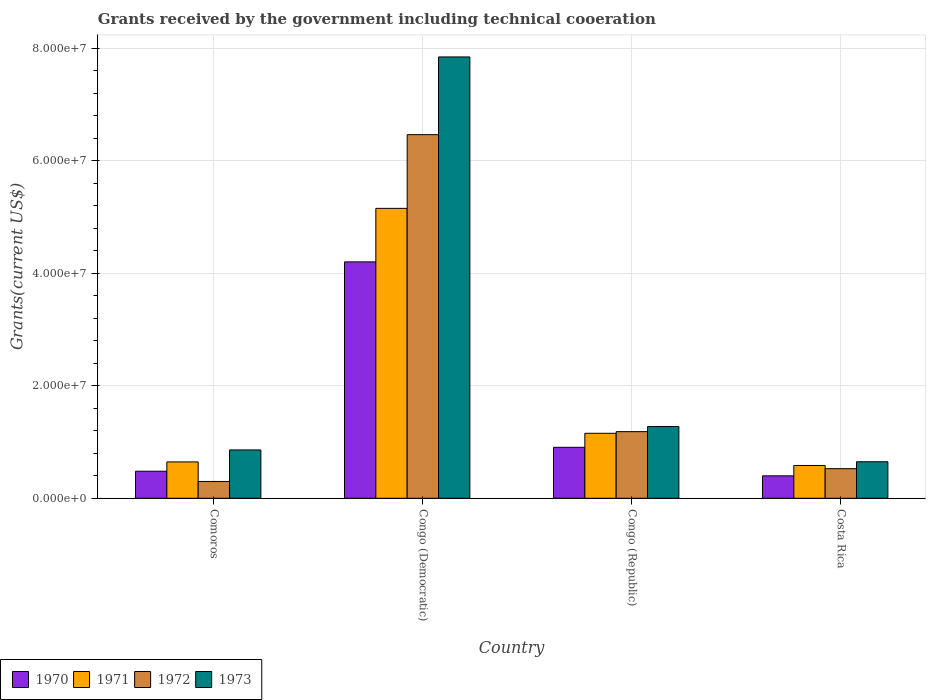How many different coloured bars are there?
Make the answer very short. 4. How many bars are there on the 4th tick from the left?
Your answer should be compact. 4. How many bars are there on the 2nd tick from the right?
Your answer should be compact. 4. What is the label of the 3rd group of bars from the left?
Offer a terse response. Congo (Republic). What is the total grants received by the government in 1972 in Congo (Republic)?
Your answer should be very brief. 1.18e+07. Across all countries, what is the maximum total grants received by the government in 1972?
Keep it short and to the point. 6.46e+07. Across all countries, what is the minimum total grants received by the government in 1972?
Provide a short and direct response. 2.99e+06. In which country was the total grants received by the government in 1971 maximum?
Your response must be concise. Congo (Democratic). In which country was the total grants received by the government in 1973 minimum?
Offer a terse response. Costa Rica. What is the total total grants received by the government in 1971 in the graph?
Your answer should be very brief. 7.54e+07. What is the difference between the total grants received by the government in 1971 in Congo (Democratic) and that in Congo (Republic)?
Make the answer very short. 4.00e+07. What is the difference between the total grants received by the government in 1970 in Comoros and the total grants received by the government in 1972 in Congo (Republic)?
Keep it short and to the point. -7.03e+06. What is the average total grants received by the government in 1970 per country?
Make the answer very short. 1.50e+07. What is the difference between the total grants received by the government of/in 1970 and total grants received by the government of/in 1971 in Comoros?
Keep it short and to the point. -1.65e+06. What is the ratio of the total grants received by the government in 1972 in Congo (Democratic) to that in Costa Rica?
Make the answer very short. 12.29. What is the difference between the highest and the second highest total grants received by the government in 1971?
Your answer should be compact. 4.00e+07. What is the difference between the highest and the lowest total grants received by the government in 1972?
Make the answer very short. 6.16e+07. Is it the case that in every country, the sum of the total grants received by the government in 1970 and total grants received by the government in 1971 is greater than the sum of total grants received by the government in 1972 and total grants received by the government in 1973?
Provide a short and direct response. No. What does the 2nd bar from the left in Costa Rica represents?
Make the answer very short. 1971. What does the 1st bar from the right in Congo (Democratic) represents?
Give a very brief answer. 1973. How many bars are there?
Provide a short and direct response. 16. Are all the bars in the graph horizontal?
Give a very brief answer. No. How many countries are there in the graph?
Your answer should be compact. 4. What is the difference between two consecutive major ticks on the Y-axis?
Ensure brevity in your answer.  2.00e+07. Are the values on the major ticks of Y-axis written in scientific E-notation?
Offer a terse response. Yes. How are the legend labels stacked?
Make the answer very short. Horizontal. What is the title of the graph?
Offer a very short reply. Grants received by the government including technical cooeration. What is the label or title of the X-axis?
Make the answer very short. Country. What is the label or title of the Y-axis?
Your response must be concise. Grants(current US$). What is the Grants(current US$) in 1970 in Comoros?
Ensure brevity in your answer.  4.81e+06. What is the Grants(current US$) in 1971 in Comoros?
Your response must be concise. 6.46e+06. What is the Grants(current US$) of 1972 in Comoros?
Ensure brevity in your answer.  2.99e+06. What is the Grants(current US$) in 1973 in Comoros?
Offer a terse response. 8.59e+06. What is the Grants(current US$) of 1970 in Congo (Democratic)?
Your answer should be very brief. 4.20e+07. What is the Grants(current US$) in 1971 in Congo (Democratic)?
Make the answer very short. 5.15e+07. What is the Grants(current US$) of 1972 in Congo (Democratic)?
Provide a short and direct response. 6.46e+07. What is the Grants(current US$) of 1973 in Congo (Democratic)?
Give a very brief answer. 7.84e+07. What is the Grants(current US$) in 1970 in Congo (Republic)?
Provide a succinct answer. 9.06e+06. What is the Grants(current US$) of 1971 in Congo (Republic)?
Your response must be concise. 1.16e+07. What is the Grants(current US$) in 1972 in Congo (Republic)?
Give a very brief answer. 1.18e+07. What is the Grants(current US$) in 1973 in Congo (Republic)?
Ensure brevity in your answer.  1.28e+07. What is the Grants(current US$) in 1970 in Costa Rica?
Keep it short and to the point. 3.99e+06. What is the Grants(current US$) in 1971 in Costa Rica?
Offer a very short reply. 5.83e+06. What is the Grants(current US$) in 1972 in Costa Rica?
Provide a succinct answer. 5.26e+06. What is the Grants(current US$) of 1973 in Costa Rica?
Your answer should be compact. 6.49e+06. Across all countries, what is the maximum Grants(current US$) in 1970?
Your answer should be very brief. 4.20e+07. Across all countries, what is the maximum Grants(current US$) of 1971?
Your response must be concise. 5.15e+07. Across all countries, what is the maximum Grants(current US$) of 1972?
Make the answer very short. 6.46e+07. Across all countries, what is the maximum Grants(current US$) of 1973?
Provide a succinct answer. 7.84e+07. Across all countries, what is the minimum Grants(current US$) in 1970?
Offer a terse response. 3.99e+06. Across all countries, what is the minimum Grants(current US$) in 1971?
Your answer should be compact. 5.83e+06. Across all countries, what is the minimum Grants(current US$) in 1972?
Your answer should be very brief. 2.99e+06. Across all countries, what is the minimum Grants(current US$) in 1973?
Keep it short and to the point. 6.49e+06. What is the total Grants(current US$) in 1970 in the graph?
Make the answer very short. 5.99e+07. What is the total Grants(current US$) of 1971 in the graph?
Provide a short and direct response. 7.54e+07. What is the total Grants(current US$) of 1972 in the graph?
Ensure brevity in your answer.  8.47e+07. What is the total Grants(current US$) in 1973 in the graph?
Give a very brief answer. 1.06e+08. What is the difference between the Grants(current US$) in 1970 in Comoros and that in Congo (Democratic)?
Give a very brief answer. -3.72e+07. What is the difference between the Grants(current US$) in 1971 in Comoros and that in Congo (Democratic)?
Your answer should be compact. -4.51e+07. What is the difference between the Grants(current US$) in 1972 in Comoros and that in Congo (Democratic)?
Provide a short and direct response. -6.16e+07. What is the difference between the Grants(current US$) in 1973 in Comoros and that in Congo (Democratic)?
Ensure brevity in your answer.  -6.98e+07. What is the difference between the Grants(current US$) of 1970 in Comoros and that in Congo (Republic)?
Your response must be concise. -4.25e+06. What is the difference between the Grants(current US$) of 1971 in Comoros and that in Congo (Republic)?
Your answer should be very brief. -5.09e+06. What is the difference between the Grants(current US$) of 1972 in Comoros and that in Congo (Republic)?
Your answer should be very brief. -8.85e+06. What is the difference between the Grants(current US$) of 1973 in Comoros and that in Congo (Republic)?
Your response must be concise. -4.16e+06. What is the difference between the Grants(current US$) of 1970 in Comoros and that in Costa Rica?
Give a very brief answer. 8.20e+05. What is the difference between the Grants(current US$) in 1971 in Comoros and that in Costa Rica?
Make the answer very short. 6.30e+05. What is the difference between the Grants(current US$) in 1972 in Comoros and that in Costa Rica?
Provide a succinct answer. -2.27e+06. What is the difference between the Grants(current US$) of 1973 in Comoros and that in Costa Rica?
Offer a terse response. 2.10e+06. What is the difference between the Grants(current US$) in 1970 in Congo (Democratic) and that in Congo (Republic)?
Provide a succinct answer. 3.30e+07. What is the difference between the Grants(current US$) in 1971 in Congo (Democratic) and that in Congo (Republic)?
Offer a terse response. 4.00e+07. What is the difference between the Grants(current US$) of 1972 in Congo (Democratic) and that in Congo (Republic)?
Ensure brevity in your answer.  5.28e+07. What is the difference between the Grants(current US$) in 1973 in Congo (Democratic) and that in Congo (Republic)?
Your answer should be compact. 6.57e+07. What is the difference between the Grants(current US$) in 1970 in Congo (Democratic) and that in Costa Rica?
Give a very brief answer. 3.80e+07. What is the difference between the Grants(current US$) of 1971 in Congo (Democratic) and that in Costa Rica?
Your answer should be compact. 4.57e+07. What is the difference between the Grants(current US$) in 1972 in Congo (Democratic) and that in Costa Rica?
Ensure brevity in your answer.  5.94e+07. What is the difference between the Grants(current US$) in 1973 in Congo (Democratic) and that in Costa Rica?
Give a very brief answer. 7.19e+07. What is the difference between the Grants(current US$) in 1970 in Congo (Republic) and that in Costa Rica?
Ensure brevity in your answer.  5.07e+06. What is the difference between the Grants(current US$) of 1971 in Congo (Republic) and that in Costa Rica?
Offer a terse response. 5.72e+06. What is the difference between the Grants(current US$) in 1972 in Congo (Republic) and that in Costa Rica?
Give a very brief answer. 6.58e+06. What is the difference between the Grants(current US$) in 1973 in Congo (Republic) and that in Costa Rica?
Provide a short and direct response. 6.26e+06. What is the difference between the Grants(current US$) of 1970 in Comoros and the Grants(current US$) of 1971 in Congo (Democratic)?
Offer a very short reply. -4.67e+07. What is the difference between the Grants(current US$) in 1970 in Comoros and the Grants(current US$) in 1972 in Congo (Democratic)?
Provide a short and direct response. -5.98e+07. What is the difference between the Grants(current US$) in 1970 in Comoros and the Grants(current US$) in 1973 in Congo (Democratic)?
Your answer should be very brief. -7.36e+07. What is the difference between the Grants(current US$) of 1971 in Comoros and the Grants(current US$) of 1972 in Congo (Democratic)?
Offer a terse response. -5.82e+07. What is the difference between the Grants(current US$) of 1971 in Comoros and the Grants(current US$) of 1973 in Congo (Democratic)?
Your answer should be very brief. -7.20e+07. What is the difference between the Grants(current US$) of 1972 in Comoros and the Grants(current US$) of 1973 in Congo (Democratic)?
Your answer should be very brief. -7.54e+07. What is the difference between the Grants(current US$) in 1970 in Comoros and the Grants(current US$) in 1971 in Congo (Republic)?
Offer a terse response. -6.74e+06. What is the difference between the Grants(current US$) of 1970 in Comoros and the Grants(current US$) of 1972 in Congo (Republic)?
Provide a short and direct response. -7.03e+06. What is the difference between the Grants(current US$) of 1970 in Comoros and the Grants(current US$) of 1973 in Congo (Republic)?
Your answer should be compact. -7.94e+06. What is the difference between the Grants(current US$) in 1971 in Comoros and the Grants(current US$) in 1972 in Congo (Republic)?
Provide a succinct answer. -5.38e+06. What is the difference between the Grants(current US$) of 1971 in Comoros and the Grants(current US$) of 1973 in Congo (Republic)?
Keep it short and to the point. -6.29e+06. What is the difference between the Grants(current US$) in 1972 in Comoros and the Grants(current US$) in 1973 in Congo (Republic)?
Ensure brevity in your answer.  -9.76e+06. What is the difference between the Grants(current US$) in 1970 in Comoros and the Grants(current US$) in 1971 in Costa Rica?
Make the answer very short. -1.02e+06. What is the difference between the Grants(current US$) of 1970 in Comoros and the Grants(current US$) of 1972 in Costa Rica?
Ensure brevity in your answer.  -4.50e+05. What is the difference between the Grants(current US$) in 1970 in Comoros and the Grants(current US$) in 1973 in Costa Rica?
Offer a terse response. -1.68e+06. What is the difference between the Grants(current US$) of 1971 in Comoros and the Grants(current US$) of 1972 in Costa Rica?
Make the answer very short. 1.20e+06. What is the difference between the Grants(current US$) of 1971 in Comoros and the Grants(current US$) of 1973 in Costa Rica?
Offer a very short reply. -3.00e+04. What is the difference between the Grants(current US$) in 1972 in Comoros and the Grants(current US$) in 1973 in Costa Rica?
Provide a succinct answer. -3.50e+06. What is the difference between the Grants(current US$) in 1970 in Congo (Democratic) and the Grants(current US$) in 1971 in Congo (Republic)?
Keep it short and to the point. 3.05e+07. What is the difference between the Grants(current US$) of 1970 in Congo (Democratic) and the Grants(current US$) of 1972 in Congo (Republic)?
Make the answer very short. 3.02e+07. What is the difference between the Grants(current US$) in 1970 in Congo (Democratic) and the Grants(current US$) in 1973 in Congo (Republic)?
Offer a terse response. 2.93e+07. What is the difference between the Grants(current US$) in 1971 in Congo (Democratic) and the Grants(current US$) in 1972 in Congo (Republic)?
Make the answer very short. 3.97e+07. What is the difference between the Grants(current US$) of 1971 in Congo (Democratic) and the Grants(current US$) of 1973 in Congo (Republic)?
Give a very brief answer. 3.88e+07. What is the difference between the Grants(current US$) in 1972 in Congo (Democratic) and the Grants(current US$) in 1973 in Congo (Republic)?
Keep it short and to the point. 5.19e+07. What is the difference between the Grants(current US$) in 1970 in Congo (Democratic) and the Grants(current US$) in 1971 in Costa Rica?
Provide a succinct answer. 3.62e+07. What is the difference between the Grants(current US$) of 1970 in Congo (Democratic) and the Grants(current US$) of 1972 in Costa Rica?
Ensure brevity in your answer.  3.68e+07. What is the difference between the Grants(current US$) of 1970 in Congo (Democratic) and the Grants(current US$) of 1973 in Costa Rica?
Offer a terse response. 3.55e+07. What is the difference between the Grants(current US$) in 1971 in Congo (Democratic) and the Grants(current US$) in 1972 in Costa Rica?
Ensure brevity in your answer.  4.63e+07. What is the difference between the Grants(current US$) in 1971 in Congo (Democratic) and the Grants(current US$) in 1973 in Costa Rica?
Offer a terse response. 4.50e+07. What is the difference between the Grants(current US$) in 1972 in Congo (Democratic) and the Grants(current US$) in 1973 in Costa Rica?
Offer a terse response. 5.81e+07. What is the difference between the Grants(current US$) of 1970 in Congo (Republic) and the Grants(current US$) of 1971 in Costa Rica?
Your response must be concise. 3.23e+06. What is the difference between the Grants(current US$) of 1970 in Congo (Republic) and the Grants(current US$) of 1972 in Costa Rica?
Keep it short and to the point. 3.80e+06. What is the difference between the Grants(current US$) of 1970 in Congo (Republic) and the Grants(current US$) of 1973 in Costa Rica?
Ensure brevity in your answer.  2.57e+06. What is the difference between the Grants(current US$) in 1971 in Congo (Republic) and the Grants(current US$) in 1972 in Costa Rica?
Offer a terse response. 6.29e+06. What is the difference between the Grants(current US$) of 1971 in Congo (Republic) and the Grants(current US$) of 1973 in Costa Rica?
Give a very brief answer. 5.06e+06. What is the difference between the Grants(current US$) of 1972 in Congo (Republic) and the Grants(current US$) of 1973 in Costa Rica?
Offer a terse response. 5.35e+06. What is the average Grants(current US$) in 1970 per country?
Your response must be concise. 1.50e+07. What is the average Grants(current US$) of 1971 per country?
Your answer should be compact. 1.88e+07. What is the average Grants(current US$) in 1972 per country?
Provide a succinct answer. 2.12e+07. What is the average Grants(current US$) in 1973 per country?
Offer a terse response. 2.66e+07. What is the difference between the Grants(current US$) of 1970 and Grants(current US$) of 1971 in Comoros?
Provide a succinct answer. -1.65e+06. What is the difference between the Grants(current US$) of 1970 and Grants(current US$) of 1972 in Comoros?
Offer a terse response. 1.82e+06. What is the difference between the Grants(current US$) in 1970 and Grants(current US$) in 1973 in Comoros?
Offer a very short reply. -3.78e+06. What is the difference between the Grants(current US$) in 1971 and Grants(current US$) in 1972 in Comoros?
Provide a succinct answer. 3.47e+06. What is the difference between the Grants(current US$) in 1971 and Grants(current US$) in 1973 in Comoros?
Provide a short and direct response. -2.13e+06. What is the difference between the Grants(current US$) of 1972 and Grants(current US$) of 1973 in Comoros?
Your response must be concise. -5.60e+06. What is the difference between the Grants(current US$) of 1970 and Grants(current US$) of 1971 in Congo (Democratic)?
Offer a very short reply. -9.51e+06. What is the difference between the Grants(current US$) of 1970 and Grants(current US$) of 1972 in Congo (Democratic)?
Offer a very short reply. -2.26e+07. What is the difference between the Grants(current US$) of 1970 and Grants(current US$) of 1973 in Congo (Democratic)?
Your answer should be compact. -3.64e+07. What is the difference between the Grants(current US$) of 1971 and Grants(current US$) of 1972 in Congo (Democratic)?
Ensure brevity in your answer.  -1.31e+07. What is the difference between the Grants(current US$) in 1971 and Grants(current US$) in 1973 in Congo (Democratic)?
Offer a very short reply. -2.69e+07. What is the difference between the Grants(current US$) in 1972 and Grants(current US$) in 1973 in Congo (Democratic)?
Give a very brief answer. -1.38e+07. What is the difference between the Grants(current US$) of 1970 and Grants(current US$) of 1971 in Congo (Republic)?
Provide a succinct answer. -2.49e+06. What is the difference between the Grants(current US$) in 1970 and Grants(current US$) in 1972 in Congo (Republic)?
Your answer should be compact. -2.78e+06. What is the difference between the Grants(current US$) in 1970 and Grants(current US$) in 1973 in Congo (Republic)?
Your response must be concise. -3.69e+06. What is the difference between the Grants(current US$) in 1971 and Grants(current US$) in 1973 in Congo (Republic)?
Ensure brevity in your answer.  -1.20e+06. What is the difference between the Grants(current US$) in 1972 and Grants(current US$) in 1973 in Congo (Republic)?
Offer a terse response. -9.10e+05. What is the difference between the Grants(current US$) of 1970 and Grants(current US$) of 1971 in Costa Rica?
Your answer should be very brief. -1.84e+06. What is the difference between the Grants(current US$) in 1970 and Grants(current US$) in 1972 in Costa Rica?
Your answer should be very brief. -1.27e+06. What is the difference between the Grants(current US$) in 1970 and Grants(current US$) in 1973 in Costa Rica?
Offer a terse response. -2.50e+06. What is the difference between the Grants(current US$) of 1971 and Grants(current US$) of 1972 in Costa Rica?
Your answer should be compact. 5.70e+05. What is the difference between the Grants(current US$) of 1971 and Grants(current US$) of 1973 in Costa Rica?
Your response must be concise. -6.60e+05. What is the difference between the Grants(current US$) in 1972 and Grants(current US$) in 1973 in Costa Rica?
Offer a very short reply. -1.23e+06. What is the ratio of the Grants(current US$) of 1970 in Comoros to that in Congo (Democratic)?
Provide a short and direct response. 0.11. What is the ratio of the Grants(current US$) of 1971 in Comoros to that in Congo (Democratic)?
Your answer should be very brief. 0.13. What is the ratio of the Grants(current US$) of 1972 in Comoros to that in Congo (Democratic)?
Make the answer very short. 0.05. What is the ratio of the Grants(current US$) of 1973 in Comoros to that in Congo (Democratic)?
Offer a terse response. 0.11. What is the ratio of the Grants(current US$) in 1970 in Comoros to that in Congo (Republic)?
Ensure brevity in your answer.  0.53. What is the ratio of the Grants(current US$) in 1971 in Comoros to that in Congo (Republic)?
Provide a succinct answer. 0.56. What is the ratio of the Grants(current US$) in 1972 in Comoros to that in Congo (Republic)?
Offer a very short reply. 0.25. What is the ratio of the Grants(current US$) of 1973 in Comoros to that in Congo (Republic)?
Give a very brief answer. 0.67. What is the ratio of the Grants(current US$) in 1970 in Comoros to that in Costa Rica?
Keep it short and to the point. 1.21. What is the ratio of the Grants(current US$) in 1971 in Comoros to that in Costa Rica?
Keep it short and to the point. 1.11. What is the ratio of the Grants(current US$) of 1972 in Comoros to that in Costa Rica?
Offer a very short reply. 0.57. What is the ratio of the Grants(current US$) of 1973 in Comoros to that in Costa Rica?
Give a very brief answer. 1.32. What is the ratio of the Grants(current US$) of 1970 in Congo (Democratic) to that in Congo (Republic)?
Make the answer very short. 4.64. What is the ratio of the Grants(current US$) of 1971 in Congo (Democratic) to that in Congo (Republic)?
Make the answer very short. 4.46. What is the ratio of the Grants(current US$) of 1972 in Congo (Democratic) to that in Congo (Republic)?
Your answer should be compact. 5.46. What is the ratio of the Grants(current US$) of 1973 in Congo (Democratic) to that in Congo (Republic)?
Offer a very short reply. 6.15. What is the ratio of the Grants(current US$) in 1970 in Congo (Democratic) to that in Costa Rica?
Your answer should be very brief. 10.53. What is the ratio of the Grants(current US$) in 1971 in Congo (Democratic) to that in Costa Rica?
Ensure brevity in your answer.  8.84. What is the ratio of the Grants(current US$) in 1972 in Congo (Democratic) to that in Costa Rica?
Provide a short and direct response. 12.29. What is the ratio of the Grants(current US$) in 1973 in Congo (Democratic) to that in Costa Rica?
Ensure brevity in your answer.  12.08. What is the ratio of the Grants(current US$) in 1970 in Congo (Republic) to that in Costa Rica?
Make the answer very short. 2.27. What is the ratio of the Grants(current US$) of 1971 in Congo (Republic) to that in Costa Rica?
Provide a succinct answer. 1.98. What is the ratio of the Grants(current US$) of 1972 in Congo (Republic) to that in Costa Rica?
Your response must be concise. 2.25. What is the ratio of the Grants(current US$) in 1973 in Congo (Republic) to that in Costa Rica?
Offer a terse response. 1.96. What is the difference between the highest and the second highest Grants(current US$) of 1970?
Your answer should be very brief. 3.30e+07. What is the difference between the highest and the second highest Grants(current US$) of 1971?
Make the answer very short. 4.00e+07. What is the difference between the highest and the second highest Grants(current US$) of 1972?
Make the answer very short. 5.28e+07. What is the difference between the highest and the second highest Grants(current US$) of 1973?
Provide a short and direct response. 6.57e+07. What is the difference between the highest and the lowest Grants(current US$) of 1970?
Make the answer very short. 3.80e+07. What is the difference between the highest and the lowest Grants(current US$) in 1971?
Offer a very short reply. 4.57e+07. What is the difference between the highest and the lowest Grants(current US$) in 1972?
Offer a very short reply. 6.16e+07. What is the difference between the highest and the lowest Grants(current US$) in 1973?
Make the answer very short. 7.19e+07. 